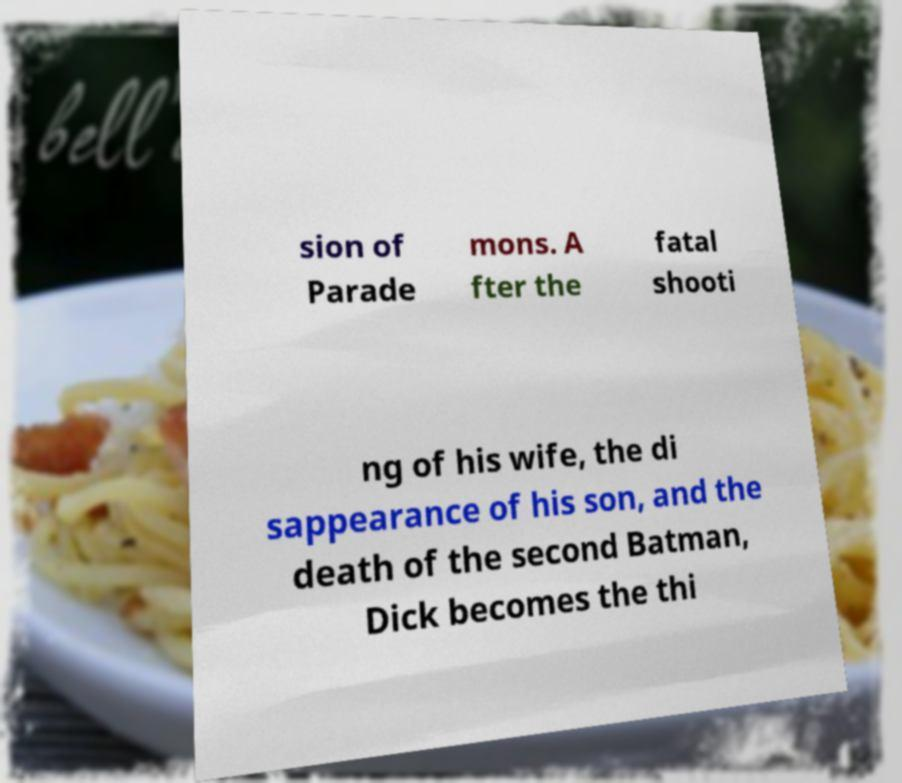What messages or text are displayed in this image? I need them in a readable, typed format. sion of Parade mons. A fter the fatal shooti ng of his wife, the di sappearance of his son, and the death of the second Batman, Dick becomes the thi 